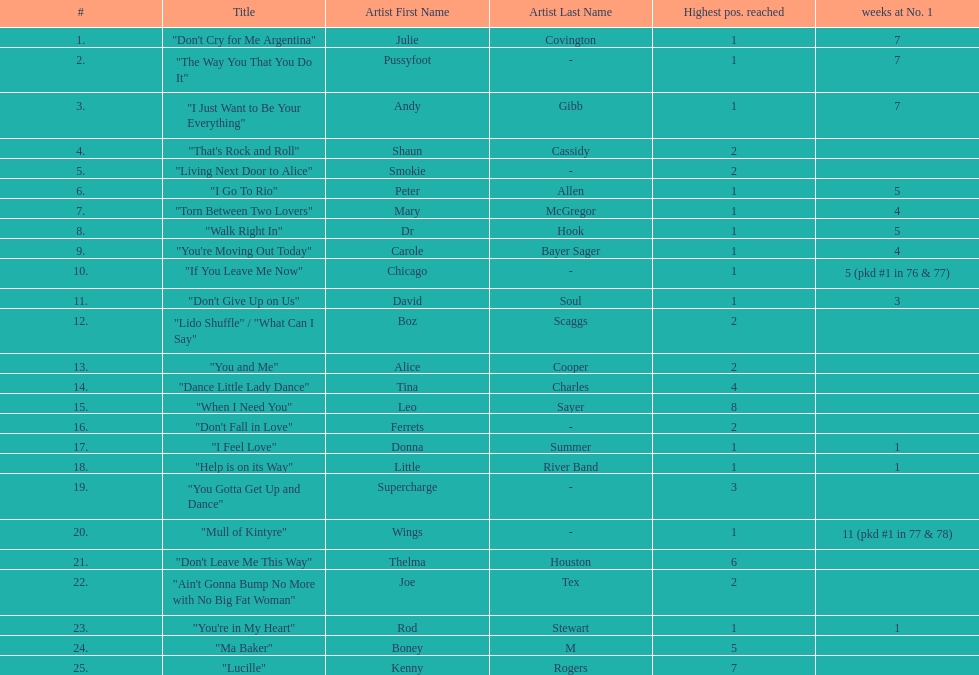Who had the most weeks at number one, according to the table? Wings. 